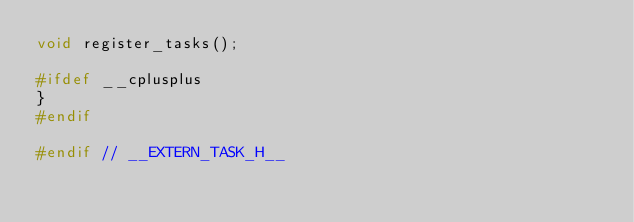<code> <loc_0><loc_0><loc_500><loc_500><_C_>void register_tasks();

#ifdef __cplusplus
}
#endif

#endif // __EXTERN_TASK_H__

</code> 